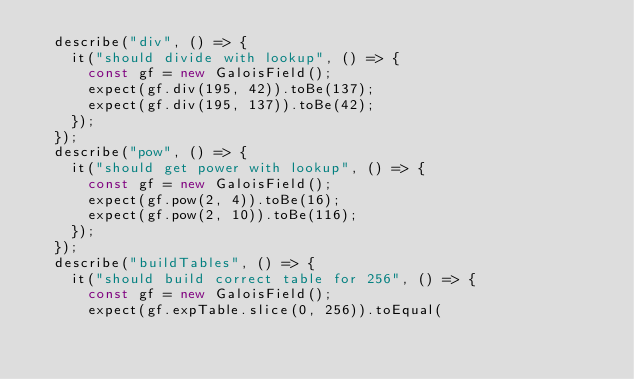Convert code to text. <code><loc_0><loc_0><loc_500><loc_500><_JavaScript_>	describe("div", () => {
		it("should divide with lookup", () => {
			const gf = new GaloisField();
			expect(gf.div(195, 42)).toBe(137);
			expect(gf.div(195, 137)).toBe(42);
		});
	});
	describe("pow", () => {
		it("should get power with lookup", () => {
			const gf = new GaloisField();
			expect(gf.pow(2, 4)).toBe(16);
			expect(gf.pow(2, 10)).toBe(116);
		});
	});
	describe("buildTables", () => {
		it("should build correct table for 256", () => {
			const gf = new GaloisField();
			expect(gf.expTable.slice(0, 256)).toEqual(</code> 